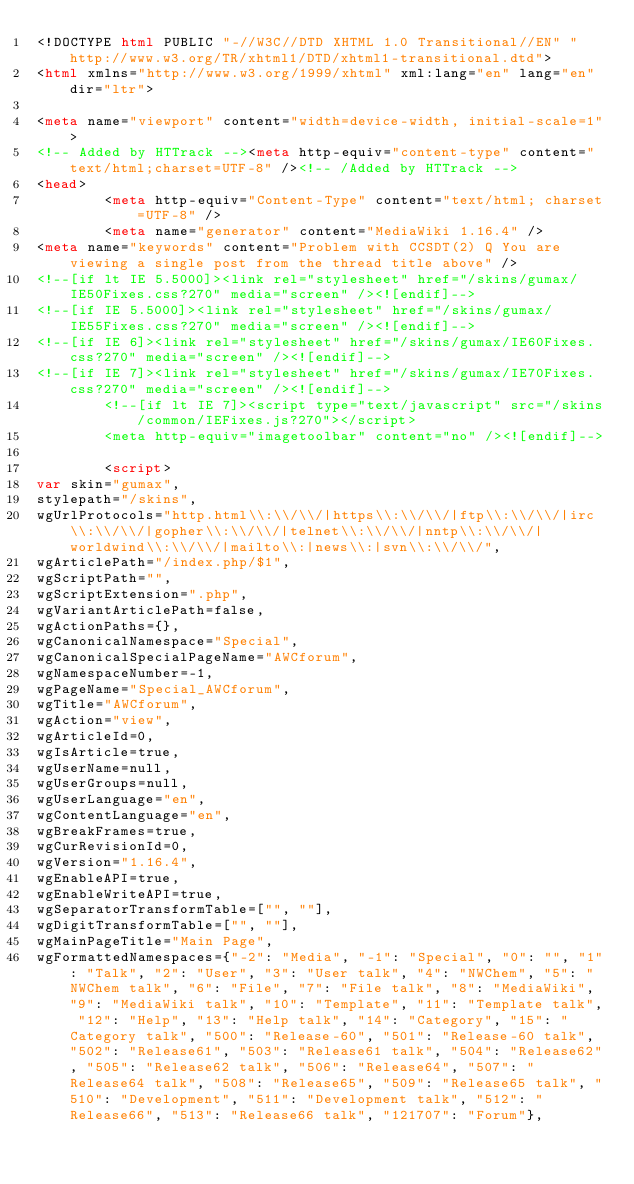<code> <loc_0><loc_0><loc_500><loc_500><_HTML_><!DOCTYPE html PUBLIC "-//W3C//DTD XHTML 1.0 Transitional//EN" "http://www.w3.org/TR/xhtml1/DTD/xhtml1-transitional.dtd">
<html xmlns="http://www.w3.org/1999/xhtml" xml:lang="en" lang="en" dir="ltr">
	
<meta name="viewport" content="width=device-width, initial-scale=1">
<!-- Added by HTTrack --><meta http-equiv="content-type" content="text/html;charset=UTF-8" /><!-- /Added by HTTrack -->
<head>
		<meta http-equiv="Content-Type" content="text/html; charset=UTF-8" />
		<meta name="generator" content="MediaWiki 1.16.4" />
<meta name="keywords" content="Problem with CCSDT(2) Q You are viewing a single post from the thread title above" />
<!--[if lt IE 5.5000]><link rel="stylesheet" href="/skins/gumax/IE50Fixes.css?270" media="screen" /><![endif]-->
<!--[if IE 5.5000]><link rel="stylesheet" href="/skins/gumax/IE55Fixes.css?270" media="screen" /><![endif]-->
<!--[if IE 6]><link rel="stylesheet" href="/skins/gumax/IE60Fixes.css?270" media="screen" /><![endif]-->
<!--[if IE 7]><link rel="stylesheet" href="/skins/gumax/IE70Fixes.css?270" media="screen" /><![endif]-->
		<!--[if lt IE 7]><script type="text/javascript" src="/skins/common/IEFixes.js?270"></script>
		<meta http-equiv="imagetoolbar" content="no" /><![endif]-->

		<script>
var skin="gumax",
stylepath="/skins",
wgUrlProtocols="http.html\\:\\/\\/|https\\:\\/\\/|ftp\\:\\/\\/|irc\\:\\/\\/|gopher\\:\\/\\/|telnet\\:\\/\\/|nntp\\:\\/\\/|worldwind\\:\\/\\/|mailto\\:|news\\:|svn\\:\\/\\/",
wgArticlePath="/index.php/$1",
wgScriptPath="",
wgScriptExtension=".php",
wgVariantArticlePath=false,
wgActionPaths={},
wgCanonicalNamespace="Special",
wgCanonicalSpecialPageName="AWCforum",
wgNamespaceNumber=-1,
wgPageName="Special_AWCforum",
wgTitle="AWCforum",
wgAction="view",
wgArticleId=0,
wgIsArticle=true,
wgUserName=null,
wgUserGroups=null,
wgUserLanguage="en",
wgContentLanguage="en",
wgBreakFrames=true,
wgCurRevisionId=0,
wgVersion="1.16.4",
wgEnableAPI=true,
wgEnableWriteAPI=true,
wgSeparatorTransformTable=["", ""],
wgDigitTransformTable=["", ""],
wgMainPageTitle="Main Page",
wgFormattedNamespaces={"-2": "Media", "-1": "Special", "0": "", "1": "Talk", "2": "User", "3": "User talk", "4": "NWChem", "5": "NWChem talk", "6": "File", "7": "File talk", "8": "MediaWiki", "9": "MediaWiki talk", "10": "Template", "11": "Template talk", "12": "Help", "13": "Help talk", "14": "Category", "15": "Category talk", "500": "Release-60", "501": "Release-60 talk", "502": "Release61", "503": "Release61 talk", "504": "Release62", "505": "Release62 talk", "506": "Release64", "507": "Release64 talk", "508": "Release65", "509": "Release65 talk", "510": "Development", "511": "Development talk", "512": "Release66", "513": "Release66 talk", "121707": "Forum"},</code> 